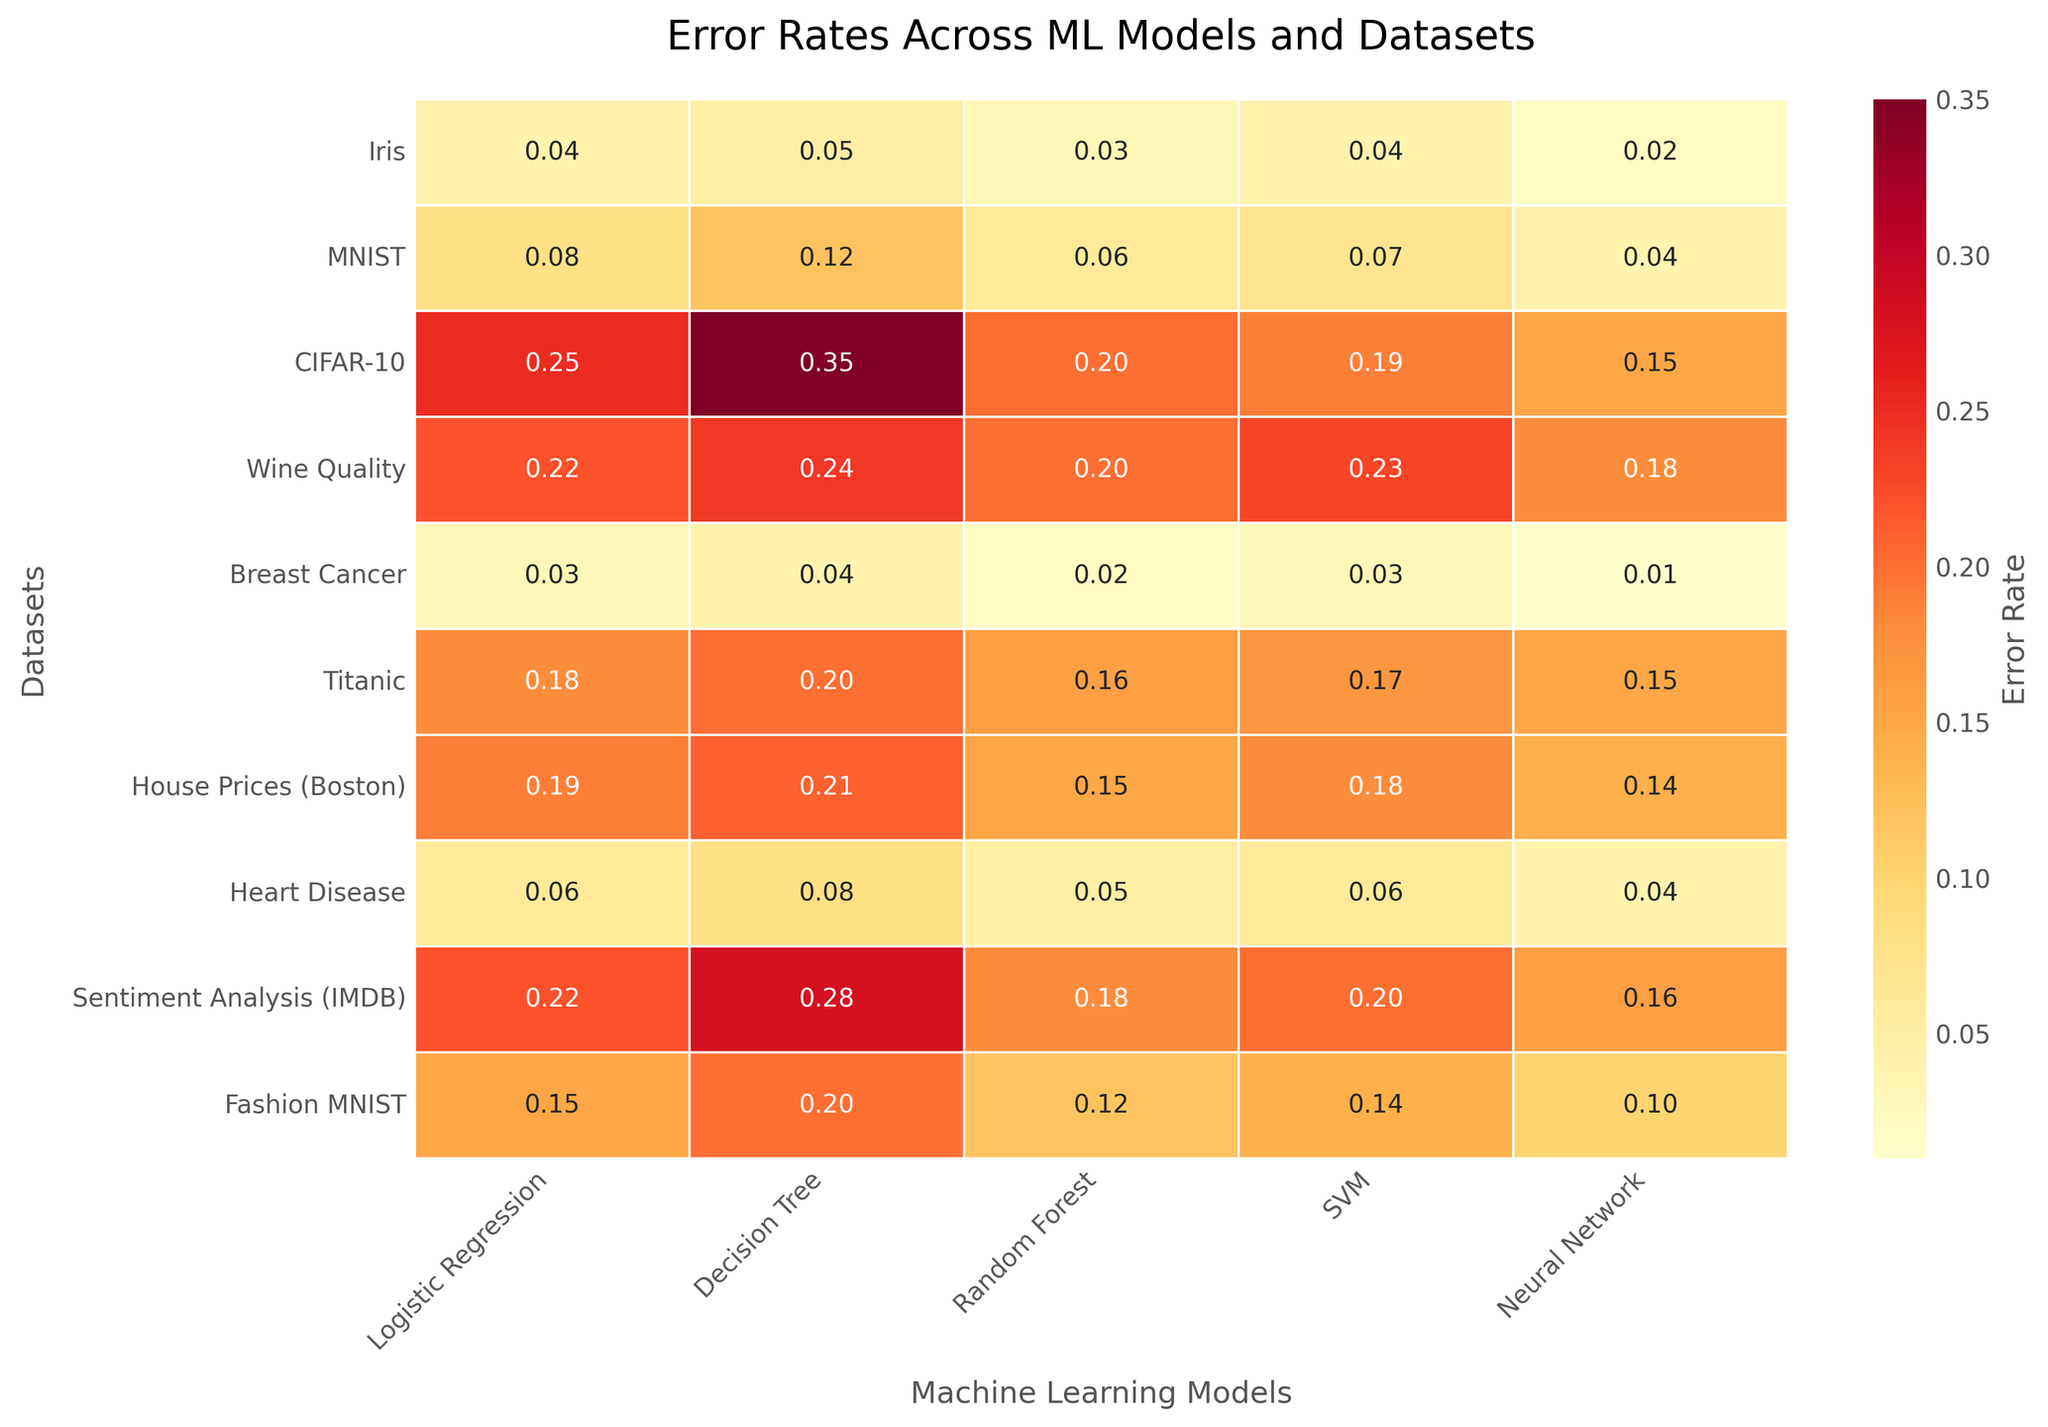What is the title of the heatmap? At the top of the heatmap, the title is clearly indicated in a larger font.
Answer: Error Rates Across ML Models and Datasets Which machine learning model has the lowest error rate for the CIFAR-10 dataset? In the row corresponding to the CIFAR-10 dataset, look for the smallest value among all the models.
Answer: Neural Network What is the error rate of the Decision Tree model on the MNIST dataset? Locate the row for the MNIST dataset, and find the value under the Decision Tree column.
Answer: 0.12 Between the Wine Quality and House Prices datasets, which one has a higher error rate for the SVM model? Compare the values for the SVM model in the Wine Quality and House Prices rows.
Answer: Wine Quality What is the average error rate across all models for the Breast Cancer dataset? Sum the error rates across all models for the Breast Cancer dataset and divide by the number of models. Calculation: (0.03 + 0.04 + 0.02 + 0.03 + 0.01)/5 = 0.026
Answer: 0.026 Which dataset has the highest error rate for the Logistic Regression model? Locate the highest value in the Logistic Regression column and note the corresponding dataset.
Answer: CIFAR-10 How much lower is the Neural Network error rate compared to the Decision Tree error rate for the Sentiment Analysis (IMDB) dataset? Subtract the Neural Network error rate from the Decision Tree error rate for the IMDB dataset.
Answer: 0.12 Which model has the most consistent error rates across datasets? Observe and compare the variation in error rates for each model across all datasets; the model with the least variation is the most consistent.
Answer: Neural Network For the Titanic dataset, what is the rank order of error rates from lowest to highest among the models? Sort the error rates for the Titanic dataset from lowest to highest.
Answer: Neural Network, Random Forest, SVM, Logistic Regression, Decision Tree 